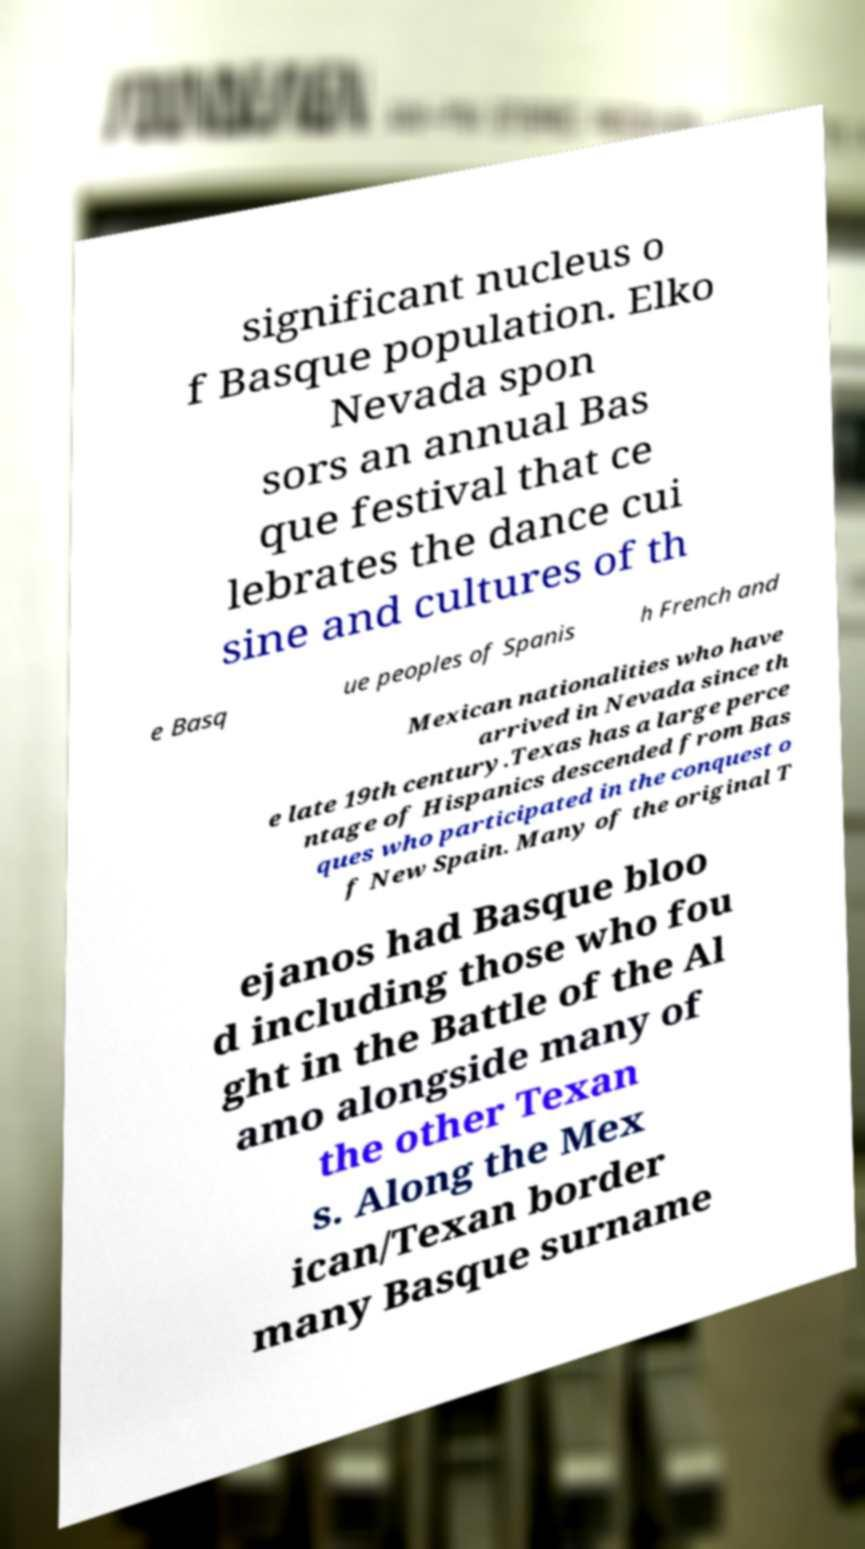Can you accurately transcribe the text from the provided image for me? significant nucleus o f Basque population. Elko Nevada spon sors an annual Bas que festival that ce lebrates the dance cui sine and cultures of th e Basq ue peoples of Spanis h French and Mexican nationalities who have arrived in Nevada since th e late 19th century.Texas has a large perce ntage of Hispanics descended from Bas ques who participated in the conquest o f New Spain. Many of the original T ejanos had Basque bloo d including those who fou ght in the Battle of the Al amo alongside many of the other Texan s. Along the Mex ican/Texan border many Basque surname 